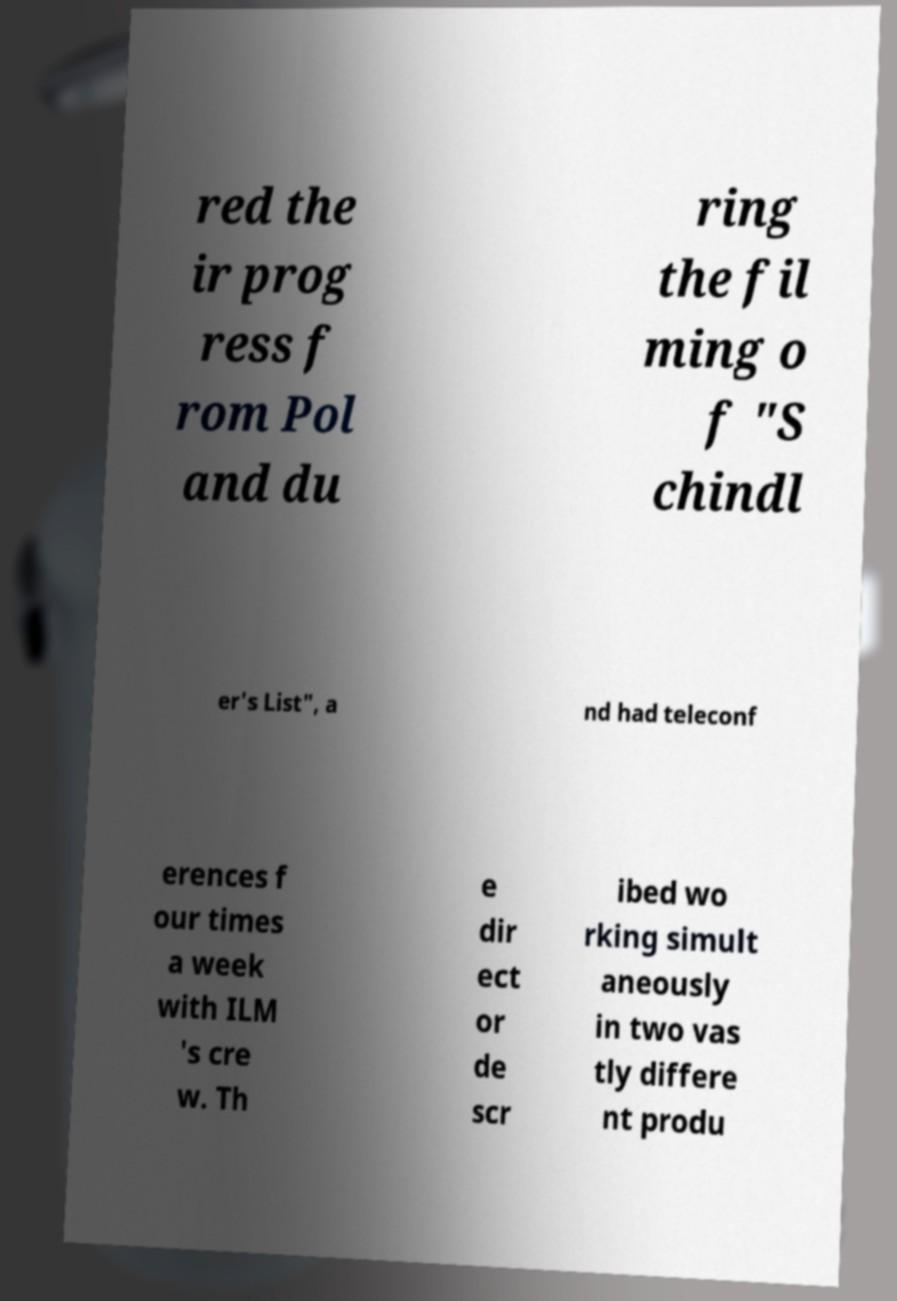I need the written content from this picture converted into text. Can you do that? red the ir prog ress f rom Pol and du ring the fil ming o f "S chindl er's List", a nd had teleconf erences f our times a week with ILM 's cre w. Th e dir ect or de scr ibed wo rking simult aneously in two vas tly differe nt produ 